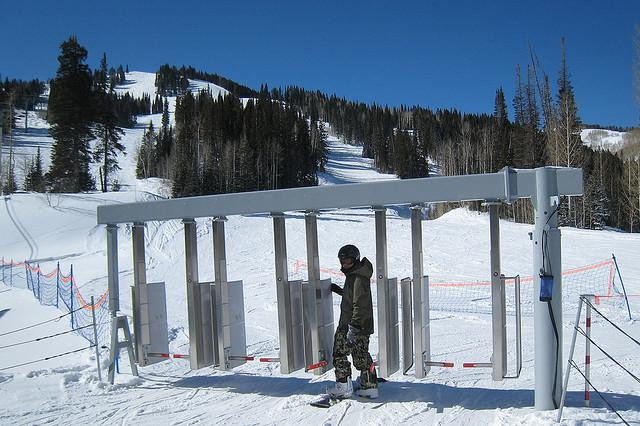What is the skier passing through?

Choices:
A) security
B) ride
C) inspection
D) gate gate 